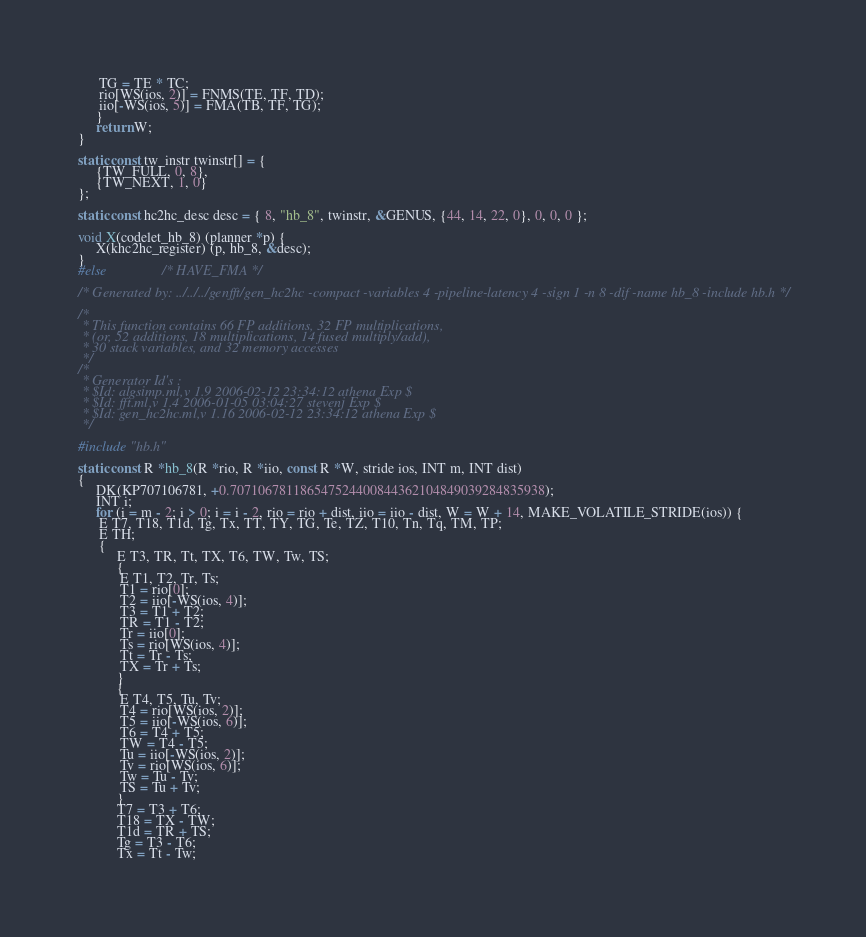Convert code to text. <code><loc_0><loc_0><loc_500><loc_500><_C_>	  TG = TE * TC;
	  rio[WS(ios, 2)] = FNMS(TE, TF, TD);
	  iio[-WS(ios, 5)] = FMA(TB, TF, TG);
     }
     return W;
}

static const tw_instr twinstr[] = {
     {TW_FULL, 0, 8},
     {TW_NEXT, 1, 0}
};

static const hc2hc_desc desc = { 8, "hb_8", twinstr, &GENUS, {44, 14, 22, 0}, 0, 0, 0 };

void X(codelet_hb_8) (planner *p) {
     X(khc2hc_register) (p, hb_8, &desc);
}
#else				/* HAVE_FMA */

/* Generated by: ../../../genfft/gen_hc2hc -compact -variables 4 -pipeline-latency 4 -sign 1 -n 8 -dif -name hb_8 -include hb.h */

/*
 * This function contains 66 FP additions, 32 FP multiplications,
 * (or, 52 additions, 18 multiplications, 14 fused multiply/add),
 * 30 stack variables, and 32 memory accesses
 */
/*
 * Generator Id's : 
 * $Id: algsimp.ml,v 1.9 2006-02-12 23:34:12 athena Exp $
 * $Id: fft.ml,v 1.4 2006-01-05 03:04:27 stevenj Exp $
 * $Id: gen_hc2hc.ml,v 1.16 2006-02-12 23:34:12 athena Exp $
 */

#include "hb.h"

static const R *hb_8(R *rio, R *iio, const R *W, stride ios, INT m, INT dist)
{
     DK(KP707106781, +0.707106781186547524400844362104849039284835938);
     INT i;
     for (i = m - 2; i > 0; i = i - 2, rio = rio + dist, iio = iio - dist, W = W + 14, MAKE_VOLATILE_STRIDE(ios)) {
	  E T7, T18, T1d, Tg, Tx, TT, TY, TG, Te, TZ, T10, Tn, Tq, TM, TP;
	  E TH;
	  {
	       E T3, TR, Tt, TX, T6, TW, Tw, TS;
	       {
		    E T1, T2, Tr, Ts;
		    T1 = rio[0];
		    T2 = iio[-WS(ios, 4)];
		    T3 = T1 + T2;
		    TR = T1 - T2;
		    Tr = iio[0];
		    Ts = rio[WS(ios, 4)];
		    Tt = Tr - Ts;
		    TX = Tr + Ts;
	       }
	       {
		    E T4, T5, Tu, Tv;
		    T4 = rio[WS(ios, 2)];
		    T5 = iio[-WS(ios, 6)];
		    T6 = T4 + T5;
		    TW = T4 - T5;
		    Tu = iio[-WS(ios, 2)];
		    Tv = rio[WS(ios, 6)];
		    Tw = Tu - Tv;
		    TS = Tu + Tv;
	       }
	       T7 = T3 + T6;
	       T18 = TX - TW;
	       T1d = TR + TS;
	       Tg = T3 - T6;
	       Tx = Tt - Tw;</code> 